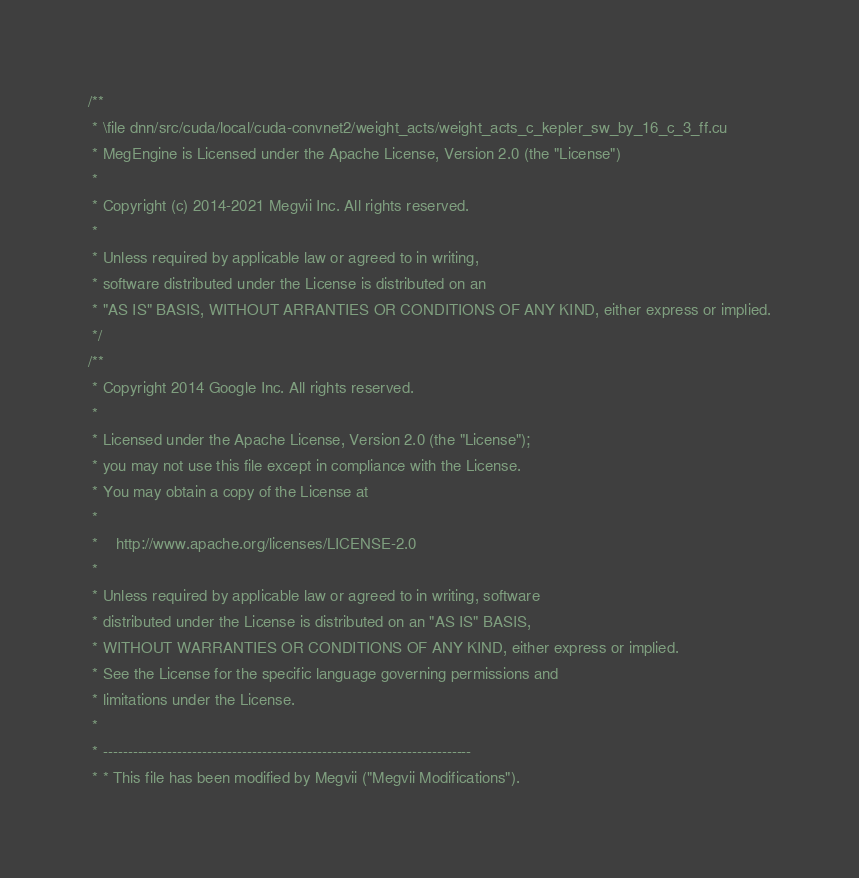Convert code to text. <code><loc_0><loc_0><loc_500><loc_500><_Cuda_>/**
 * \file dnn/src/cuda/local/cuda-convnet2/weight_acts/weight_acts_c_kepler_sw_by_16_c_3_ff.cu
 * MegEngine is Licensed under the Apache License, Version 2.0 (the "License")
 *
 * Copyright (c) 2014-2021 Megvii Inc. All rights reserved.
 *
 * Unless required by applicable law or agreed to in writing,
 * software distributed under the License is distributed on an
 * "AS IS" BASIS, WITHOUT ARRANTIES OR CONDITIONS OF ANY KIND, either express or implied.
 */
/**
 * Copyright 2014 Google Inc. All rights reserved.
 *
 * Licensed under the Apache License, Version 2.0 (the "License");
 * you may not use this file except in compliance with the License.
 * You may obtain a copy of the License at
 *
 *    http://www.apache.org/licenses/LICENSE-2.0
 *
 * Unless required by applicable law or agreed to in writing, software
 * distributed under the License is distributed on an "AS IS" BASIS,
 * WITHOUT WARRANTIES OR CONDITIONS OF ANY KIND, either express or implied.
 * See the License for the specific language governing permissions and
 * limitations under the License.
 *
 * --------------------------------------------------------------------------
 * * This file has been modified by Megvii ("Megvii Modifications").</code> 